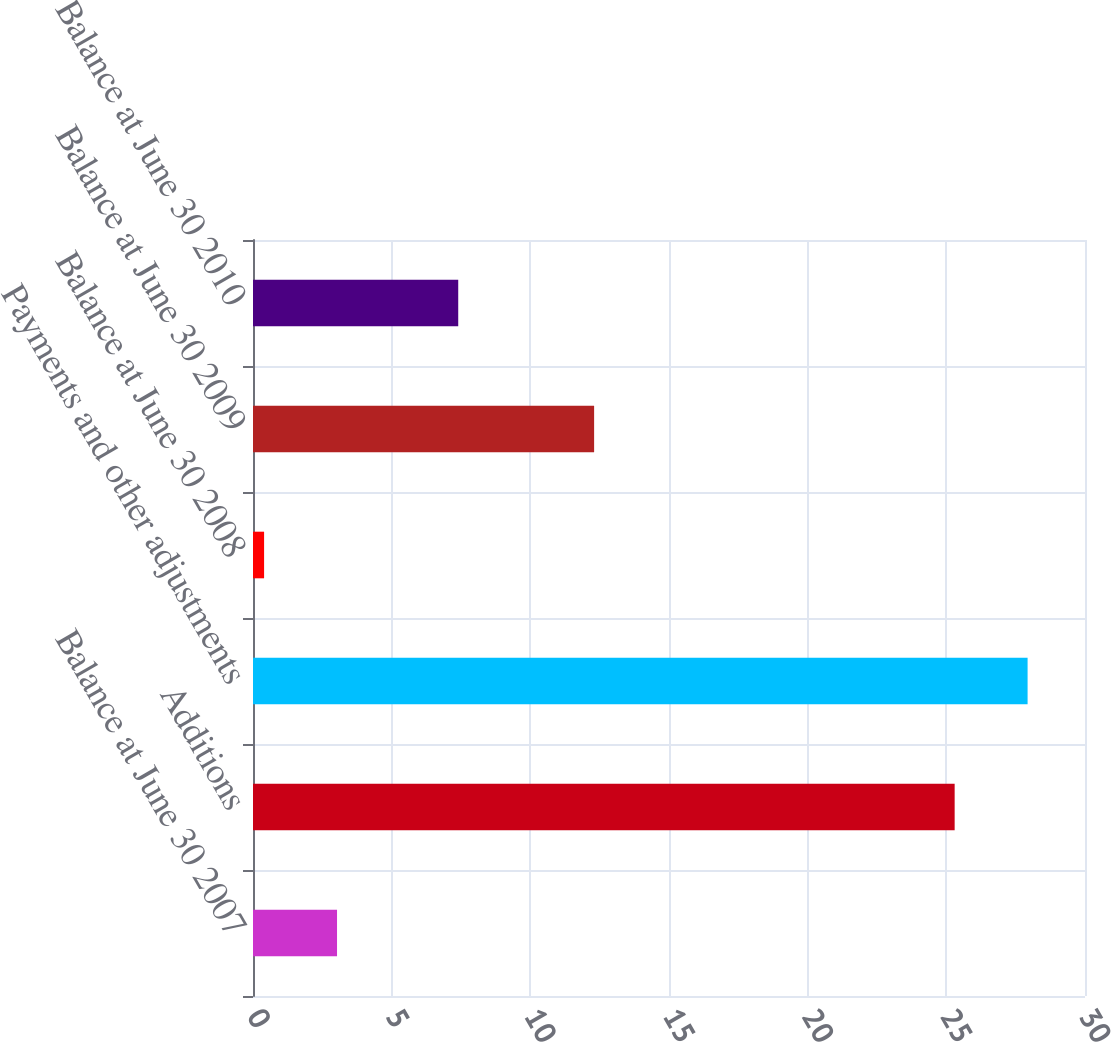<chart> <loc_0><loc_0><loc_500><loc_500><bar_chart><fcel>Balance at June 30 2007<fcel>Additions<fcel>Payments and other adjustments<fcel>Balance at June 30 2008<fcel>Balance at June 30 2009<fcel>Balance at June 30 2010<nl><fcel>3.03<fcel>25.3<fcel>27.93<fcel>0.4<fcel>12.3<fcel>7.4<nl></chart> 